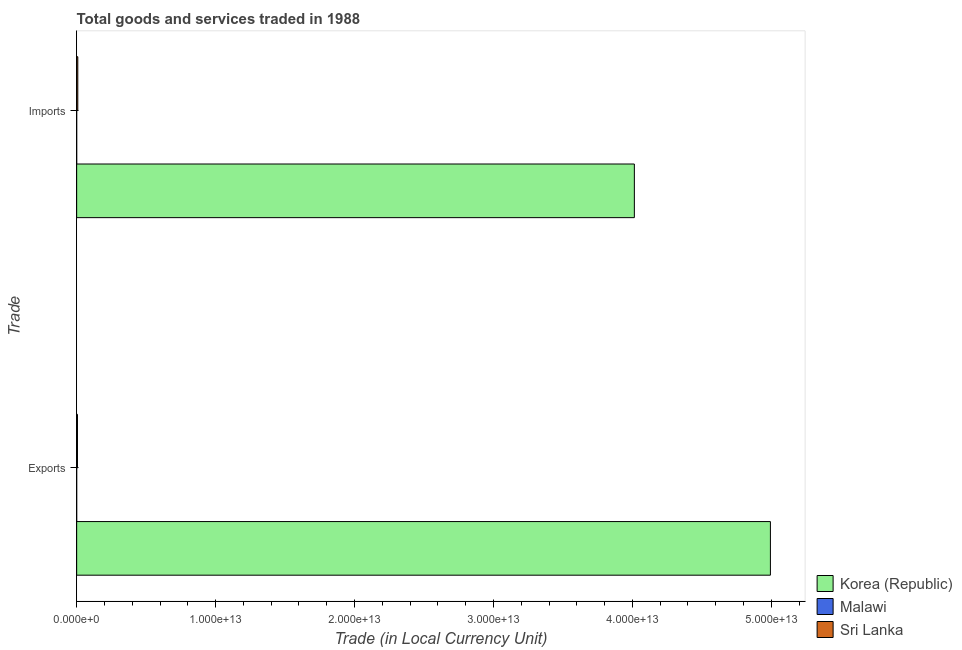Are the number of bars on each tick of the Y-axis equal?
Provide a succinct answer. Yes. What is the label of the 1st group of bars from the top?
Your answer should be very brief. Imports. What is the imports of goods and services in Korea (Republic)?
Make the answer very short. 4.01e+13. Across all countries, what is the maximum export of goods and services?
Give a very brief answer. 4.99e+13. Across all countries, what is the minimum export of goods and services?
Offer a terse response. 8.24e+08. In which country was the export of goods and services minimum?
Provide a succinct answer. Malawi. What is the total imports of goods and services in the graph?
Your response must be concise. 4.02e+13. What is the difference between the export of goods and services in Malawi and that in Korea (Republic)?
Offer a terse response. -4.99e+13. What is the difference between the export of goods and services in Malawi and the imports of goods and services in Korea (Republic)?
Your answer should be very brief. -4.01e+13. What is the average export of goods and services per country?
Your response must be concise. 1.67e+13. What is the difference between the imports of goods and services and export of goods and services in Malawi?
Your answer should be very brief. 3.26e+08. In how many countries, is the imports of goods and services greater than 50000000000000 LCU?
Your response must be concise. 0. What is the ratio of the export of goods and services in Malawi to that in Korea (Republic)?
Your answer should be compact. 1.6506368859172218e-5. In how many countries, is the export of goods and services greater than the average export of goods and services taken over all countries?
Your answer should be compact. 1. What does the 1st bar from the bottom in Imports represents?
Your response must be concise. Korea (Republic). What is the difference between two consecutive major ticks on the X-axis?
Keep it short and to the point. 1.00e+13. Are the values on the major ticks of X-axis written in scientific E-notation?
Give a very brief answer. Yes. Does the graph contain any zero values?
Ensure brevity in your answer.  No. Where does the legend appear in the graph?
Offer a terse response. Bottom right. How are the legend labels stacked?
Offer a very short reply. Vertical. What is the title of the graph?
Give a very brief answer. Total goods and services traded in 1988. What is the label or title of the X-axis?
Provide a short and direct response. Trade (in Local Currency Unit). What is the label or title of the Y-axis?
Make the answer very short. Trade. What is the Trade (in Local Currency Unit) of Korea (Republic) in Exports?
Offer a terse response. 4.99e+13. What is the Trade (in Local Currency Unit) of Malawi in Exports?
Your answer should be compact. 8.24e+08. What is the Trade (in Local Currency Unit) of Sri Lanka in Exports?
Your answer should be very brief. 5.79e+1. What is the Trade (in Local Currency Unit) in Korea (Republic) in Imports?
Your answer should be compact. 4.01e+13. What is the Trade (in Local Currency Unit) of Malawi in Imports?
Provide a short and direct response. 1.15e+09. What is the Trade (in Local Currency Unit) of Sri Lanka in Imports?
Keep it short and to the point. 8.18e+1. Across all Trade, what is the maximum Trade (in Local Currency Unit) of Korea (Republic)?
Give a very brief answer. 4.99e+13. Across all Trade, what is the maximum Trade (in Local Currency Unit) in Malawi?
Provide a succinct answer. 1.15e+09. Across all Trade, what is the maximum Trade (in Local Currency Unit) of Sri Lanka?
Give a very brief answer. 8.18e+1. Across all Trade, what is the minimum Trade (in Local Currency Unit) of Korea (Republic)?
Make the answer very short. 4.01e+13. Across all Trade, what is the minimum Trade (in Local Currency Unit) in Malawi?
Your answer should be compact. 8.24e+08. Across all Trade, what is the minimum Trade (in Local Currency Unit) of Sri Lanka?
Provide a short and direct response. 5.79e+1. What is the total Trade (in Local Currency Unit) in Korea (Republic) in the graph?
Provide a succinct answer. 9.01e+13. What is the total Trade (in Local Currency Unit) in Malawi in the graph?
Provide a succinct answer. 1.97e+09. What is the total Trade (in Local Currency Unit) in Sri Lanka in the graph?
Keep it short and to the point. 1.40e+11. What is the difference between the Trade (in Local Currency Unit) of Korea (Republic) in Exports and that in Imports?
Provide a short and direct response. 9.79e+12. What is the difference between the Trade (in Local Currency Unit) of Malawi in Exports and that in Imports?
Your response must be concise. -3.26e+08. What is the difference between the Trade (in Local Currency Unit) of Sri Lanka in Exports and that in Imports?
Your answer should be very brief. -2.39e+1. What is the difference between the Trade (in Local Currency Unit) in Korea (Republic) in Exports and the Trade (in Local Currency Unit) in Malawi in Imports?
Make the answer very short. 4.99e+13. What is the difference between the Trade (in Local Currency Unit) of Korea (Republic) in Exports and the Trade (in Local Currency Unit) of Sri Lanka in Imports?
Make the answer very short. 4.99e+13. What is the difference between the Trade (in Local Currency Unit) in Malawi in Exports and the Trade (in Local Currency Unit) in Sri Lanka in Imports?
Ensure brevity in your answer.  -8.09e+1. What is the average Trade (in Local Currency Unit) in Korea (Republic) per Trade?
Provide a short and direct response. 4.50e+13. What is the average Trade (in Local Currency Unit) in Malawi per Trade?
Your answer should be compact. 9.87e+08. What is the average Trade (in Local Currency Unit) in Sri Lanka per Trade?
Your answer should be compact. 6.98e+1. What is the difference between the Trade (in Local Currency Unit) in Korea (Republic) and Trade (in Local Currency Unit) in Malawi in Exports?
Offer a very short reply. 4.99e+13. What is the difference between the Trade (in Local Currency Unit) in Korea (Republic) and Trade (in Local Currency Unit) in Sri Lanka in Exports?
Make the answer very short. 4.99e+13. What is the difference between the Trade (in Local Currency Unit) in Malawi and Trade (in Local Currency Unit) in Sri Lanka in Exports?
Provide a short and direct response. -5.71e+1. What is the difference between the Trade (in Local Currency Unit) in Korea (Republic) and Trade (in Local Currency Unit) in Malawi in Imports?
Your answer should be very brief. 4.01e+13. What is the difference between the Trade (in Local Currency Unit) of Korea (Republic) and Trade (in Local Currency Unit) of Sri Lanka in Imports?
Your answer should be compact. 4.01e+13. What is the difference between the Trade (in Local Currency Unit) of Malawi and Trade (in Local Currency Unit) of Sri Lanka in Imports?
Ensure brevity in your answer.  -8.06e+1. What is the ratio of the Trade (in Local Currency Unit) in Korea (Republic) in Exports to that in Imports?
Offer a terse response. 1.24. What is the ratio of the Trade (in Local Currency Unit) of Malawi in Exports to that in Imports?
Give a very brief answer. 0.72. What is the ratio of the Trade (in Local Currency Unit) of Sri Lanka in Exports to that in Imports?
Give a very brief answer. 0.71. What is the difference between the highest and the second highest Trade (in Local Currency Unit) of Korea (Republic)?
Ensure brevity in your answer.  9.79e+12. What is the difference between the highest and the second highest Trade (in Local Currency Unit) in Malawi?
Your response must be concise. 3.26e+08. What is the difference between the highest and the second highest Trade (in Local Currency Unit) of Sri Lanka?
Keep it short and to the point. 2.39e+1. What is the difference between the highest and the lowest Trade (in Local Currency Unit) in Korea (Republic)?
Make the answer very short. 9.79e+12. What is the difference between the highest and the lowest Trade (in Local Currency Unit) of Malawi?
Offer a terse response. 3.26e+08. What is the difference between the highest and the lowest Trade (in Local Currency Unit) of Sri Lanka?
Offer a very short reply. 2.39e+1. 